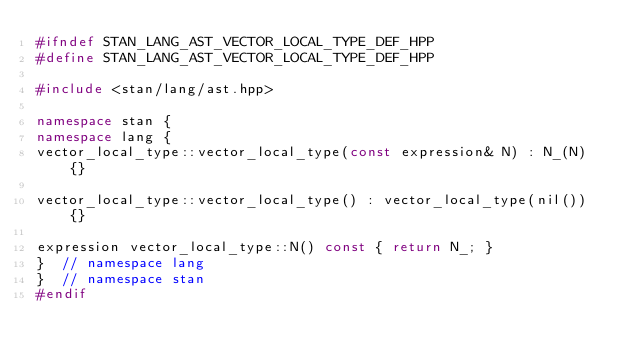Convert code to text. <code><loc_0><loc_0><loc_500><loc_500><_C++_>#ifndef STAN_LANG_AST_VECTOR_LOCAL_TYPE_DEF_HPP
#define STAN_LANG_AST_VECTOR_LOCAL_TYPE_DEF_HPP

#include <stan/lang/ast.hpp>

namespace stan {
namespace lang {
vector_local_type::vector_local_type(const expression& N) : N_(N) {}

vector_local_type::vector_local_type() : vector_local_type(nil()) {}

expression vector_local_type::N() const { return N_; }
}  // namespace lang
}  // namespace stan
#endif
</code> 